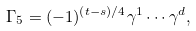Convert formula to latex. <formula><loc_0><loc_0><loc_500><loc_500>\Gamma _ { 5 } = ( - 1 ) ^ { ( t - s ) / 4 } \gamma ^ { 1 } \cdots \gamma ^ { d } ,</formula> 